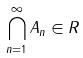<formula> <loc_0><loc_0><loc_500><loc_500>\bigcap _ { n = 1 } ^ { \infty } A _ { n } \in R</formula> 